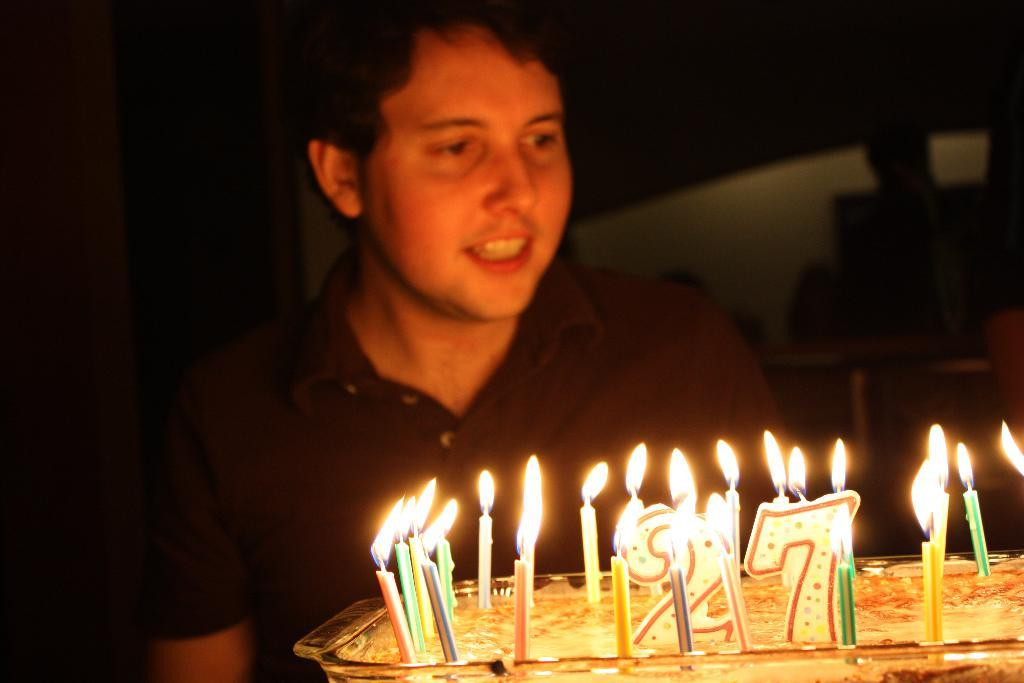What is on the tray that is visible in the image? There is a tray with cake in the image. What is placed on the cake? There are candles inside the tray. Can you describe the person behind the tray? There is a man wearing a black t-shirt behind the tray. What scent can be smelled coming from the mom in the image? There is no mom present in the image, so it is not possible to determine any scent. 